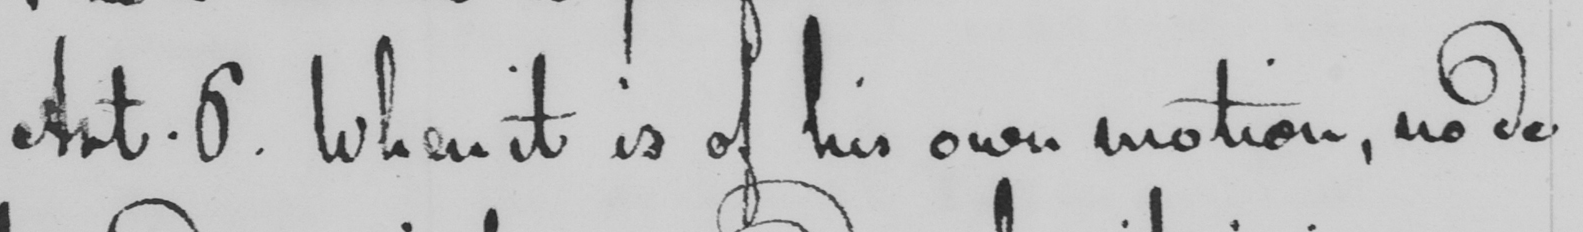Can you tell me what this handwritten text says? Art . 6 . When it is of his own motion , no de- 